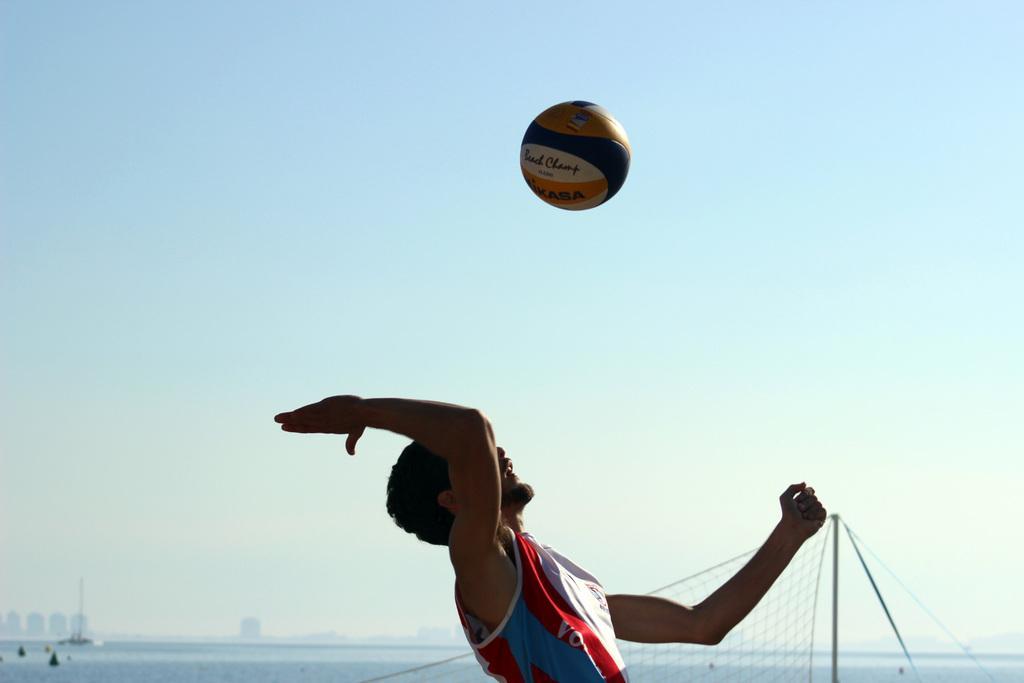Can you describe this image briefly? In this image there is a man towards the bottom of the image, there is a ball, there is text on the ball, there is a net towards the bottom of the image, there are objects towards the bottom of the image, there is ground towards the bottom of the image, there are objects on the ground, there is a pole, there are buildings towards the left of the image, at the background of the image there is the sky. 